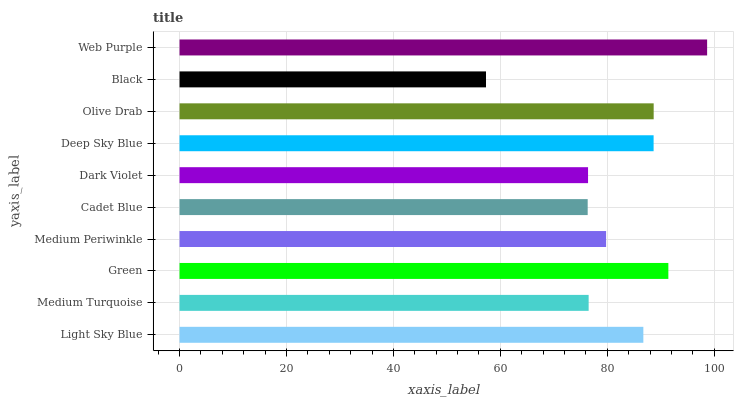Is Black the minimum?
Answer yes or no. Yes. Is Web Purple the maximum?
Answer yes or no. Yes. Is Medium Turquoise the minimum?
Answer yes or no. No. Is Medium Turquoise the maximum?
Answer yes or no. No. Is Light Sky Blue greater than Medium Turquoise?
Answer yes or no. Yes. Is Medium Turquoise less than Light Sky Blue?
Answer yes or no. Yes. Is Medium Turquoise greater than Light Sky Blue?
Answer yes or no. No. Is Light Sky Blue less than Medium Turquoise?
Answer yes or no. No. Is Light Sky Blue the high median?
Answer yes or no. Yes. Is Medium Periwinkle the low median?
Answer yes or no. Yes. Is Medium Turquoise the high median?
Answer yes or no. No. Is Olive Drab the low median?
Answer yes or no. No. 